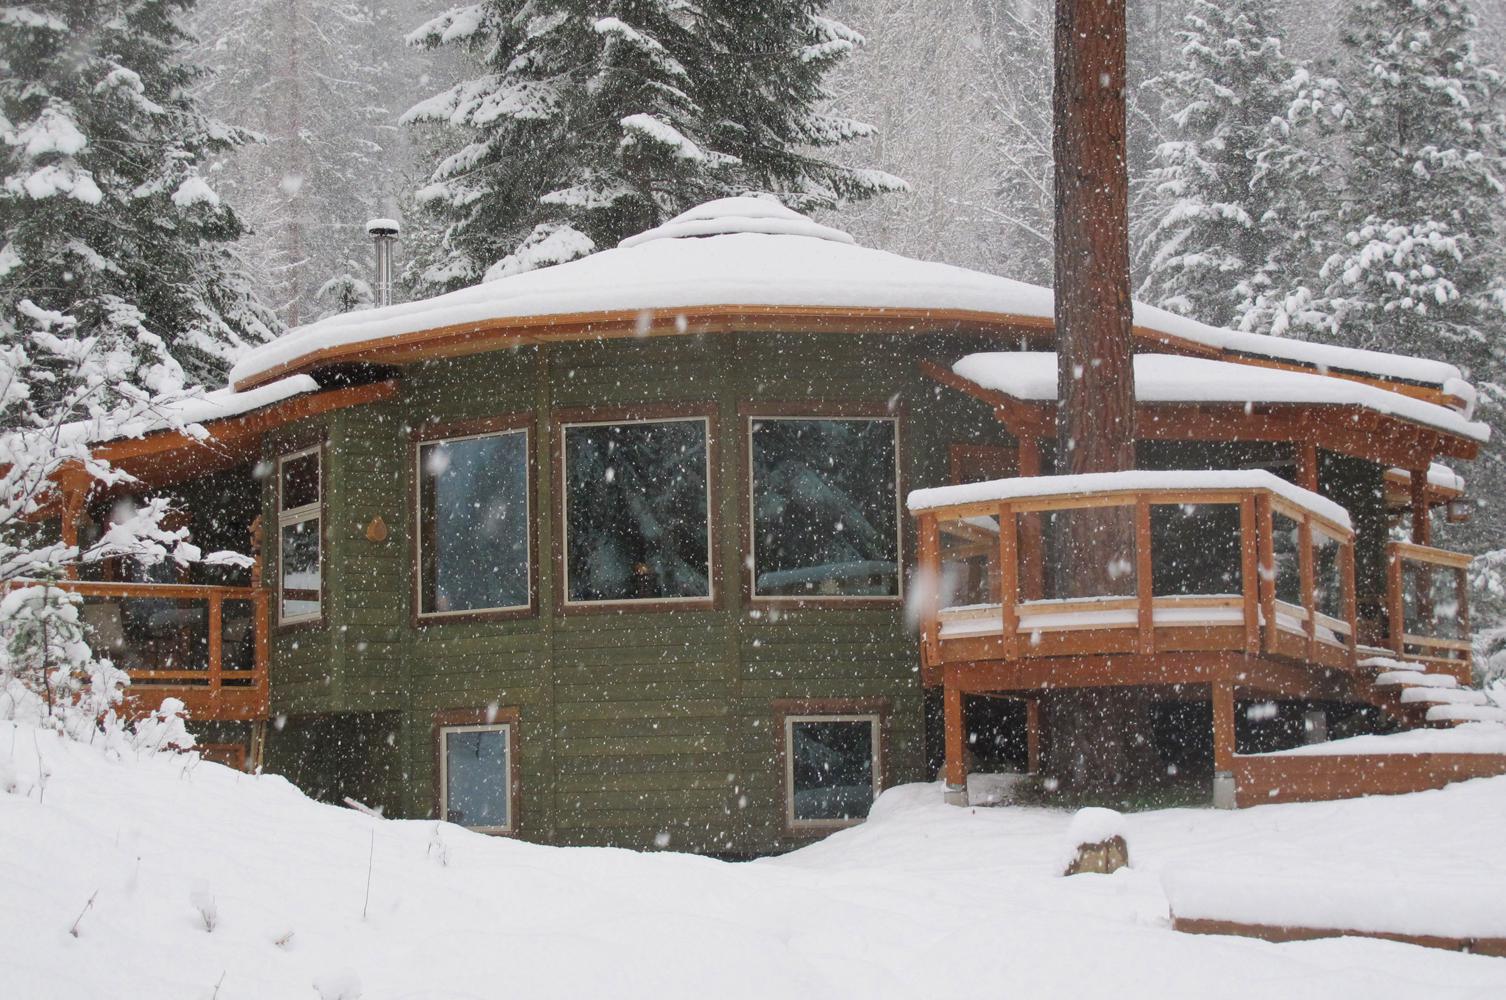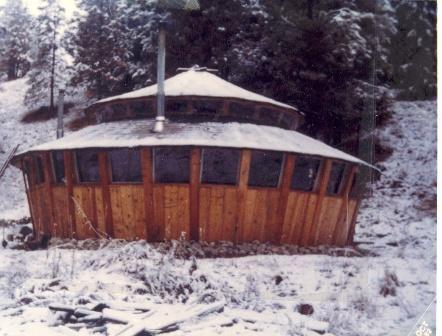The first image is the image on the left, the second image is the image on the right. Examine the images to the left and right. Is the description "Two round houses are sitting in snowy areas." accurate? Answer yes or no. Yes. The first image is the image on the left, the second image is the image on the right. Assess this claim about the two images: "An image shows side-by-side joined structures, both with cone/dome tops.". Correct or not? Answer yes or no. No. 